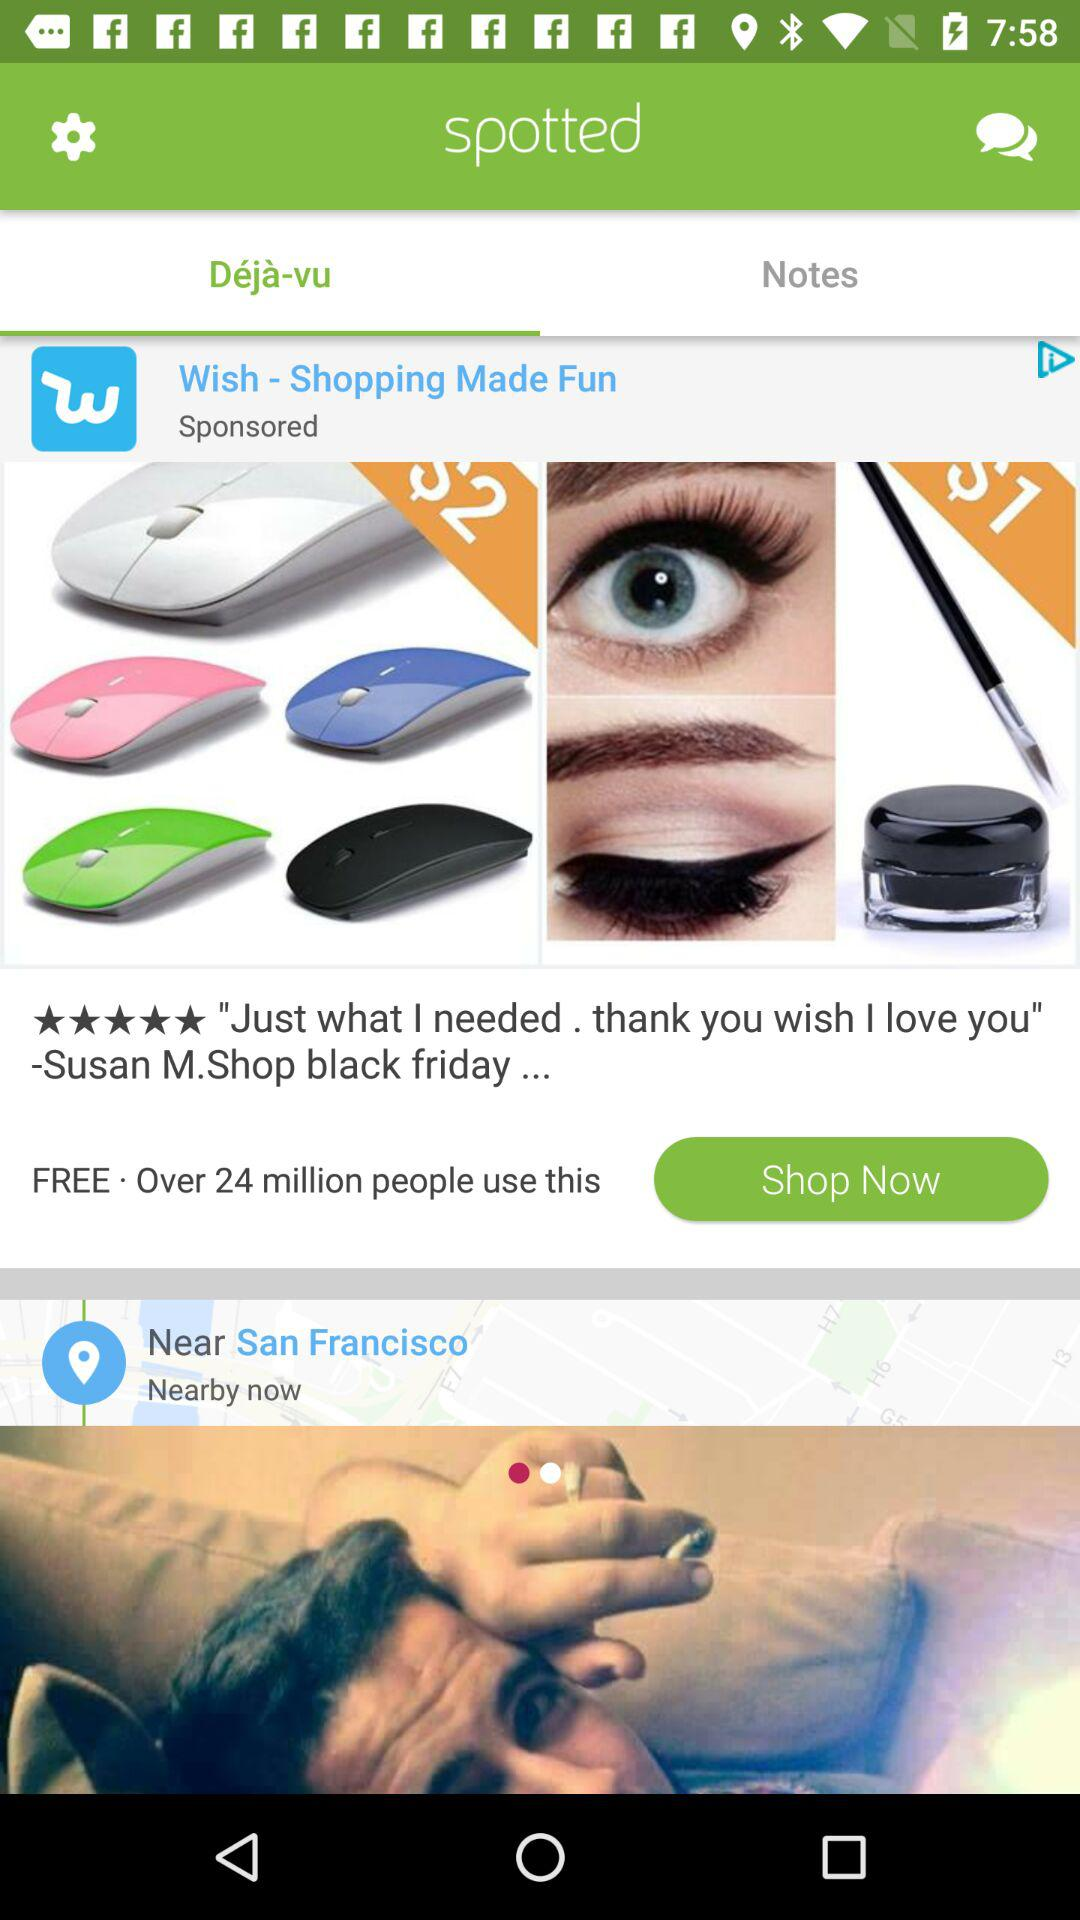What is the rating? The rating is 5 stars. 